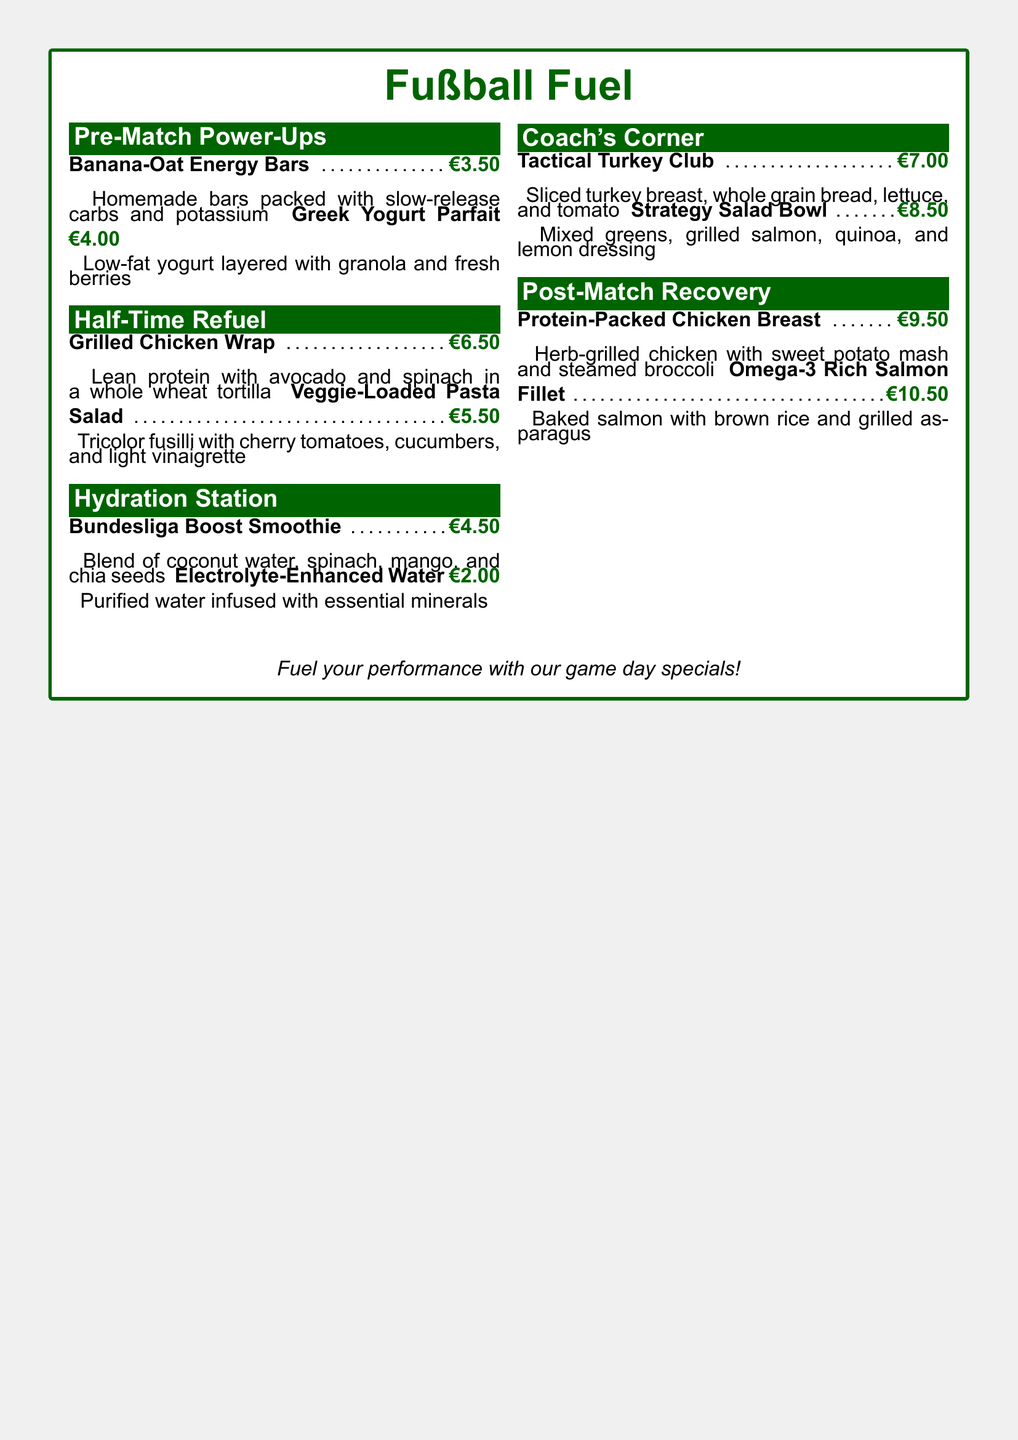What is the cost of the Greek Yogurt Parfait? The cost of the Greek Yogurt Parfait is listed in the menu under "Pre-Match Power-Ups."
Answer: €4.00 How many items are listed in the "Half-Time Refuel" section? The menu shows four items in total, with two under "Half-Time Refuel."
Answer: 2 What is the main ingredient in the "Protein-Packed Chicken Breast"? The ingredient is specified in the description of the item under "Post-Match Recovery."
Answer: Chicken What is included in the "Bundesliga Boost Smoothie"? The smoothie includes coconut water, spinach, mango, and chia seeds as per the description in the "Hydration Station."
Answer: Coconut water, spinach, mango, and chia seeds What type of bread is used in the "Tactical Turkey Club"? The type of bread is mentioned in the item description in "Coach's Corner."
Answer: Whole grain bread What section contains the "Omega-3 Rich Salmon Fillet"? The section for "Omega-3 Rich Salmon Fillet" is found under the "Post-Match Recovery."
Answer: Post-Match Recovery How much does the "Veggie-Loaded Pasta Salad" cost? The cost is indicated next to the item listed in the "Half-Time Refuel" section.
Answer: €5.50 Which menu section features smoothies? The section that mentions smoothies is indicated in the title of the relevant section.
Answer: Hydration Station How is the "Strategy Salad Bowl" described in terms of its key ingredients? The ingredients listed include mixed greens, grilled salmon, quinoa, and lemon dressing under "Coach's Corner."
Answer: Mixed greens, grilled salmon, quinoa, and lemon dressing 